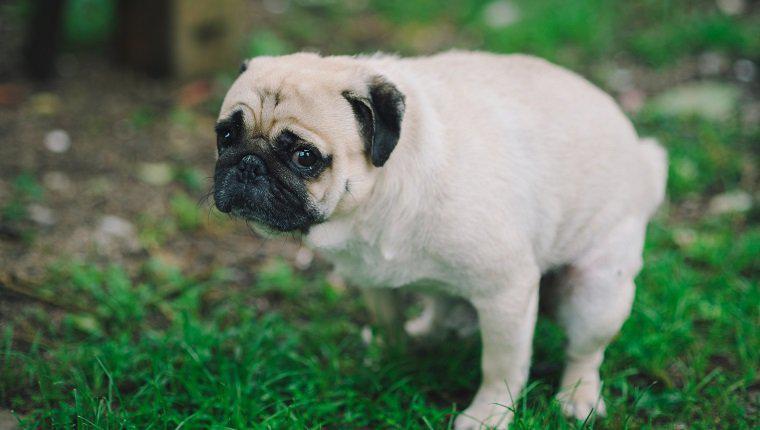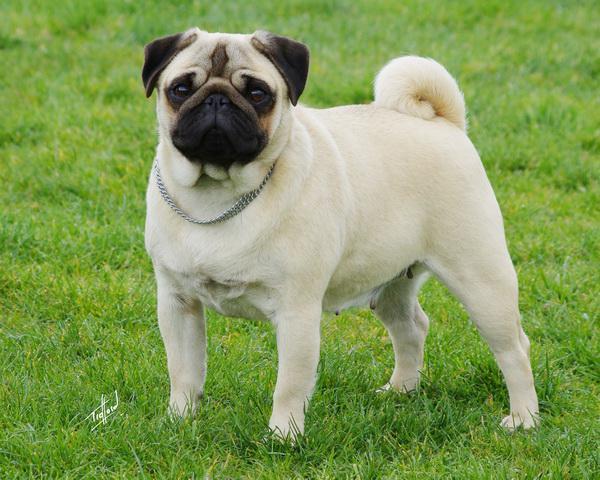The first image is the image on the left, the second image is the image on the right. Given the left and right images, does the statement "Each image shows one dog sitting and one dog standing." hold true? Answer yes or no. No. The first image is the image on the left, the second image is the image on the right. Evaluate the accuracy of this statement regarding the images: "The lighter colored dog is sitting in the grass.". Is it true? Answer yes or no. No. 